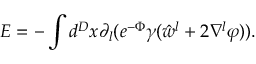<formula> <loc_0><loc_0><loc_500><loc_500>E = - \int d ^ { D } x \partial _ { l } ( e ^ { - \Phi } \gamma ( \hat { w } ^ { l } + 2 \nabla ^ { l } \varphi ) ) .</formula> 